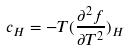Convert formula to latex. <formula><loc_0><loc_0><loc_500><loc_500>c _ { H } = - T ( \frac { \partial ^ { 2 } f } { \partial T ^ { 2 } } ) _ { H }</formula> 